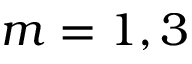Convert formula to latex. <formula><loc_0><loc_0><loc_500><loc_500>m = 1 , 3</formula> 